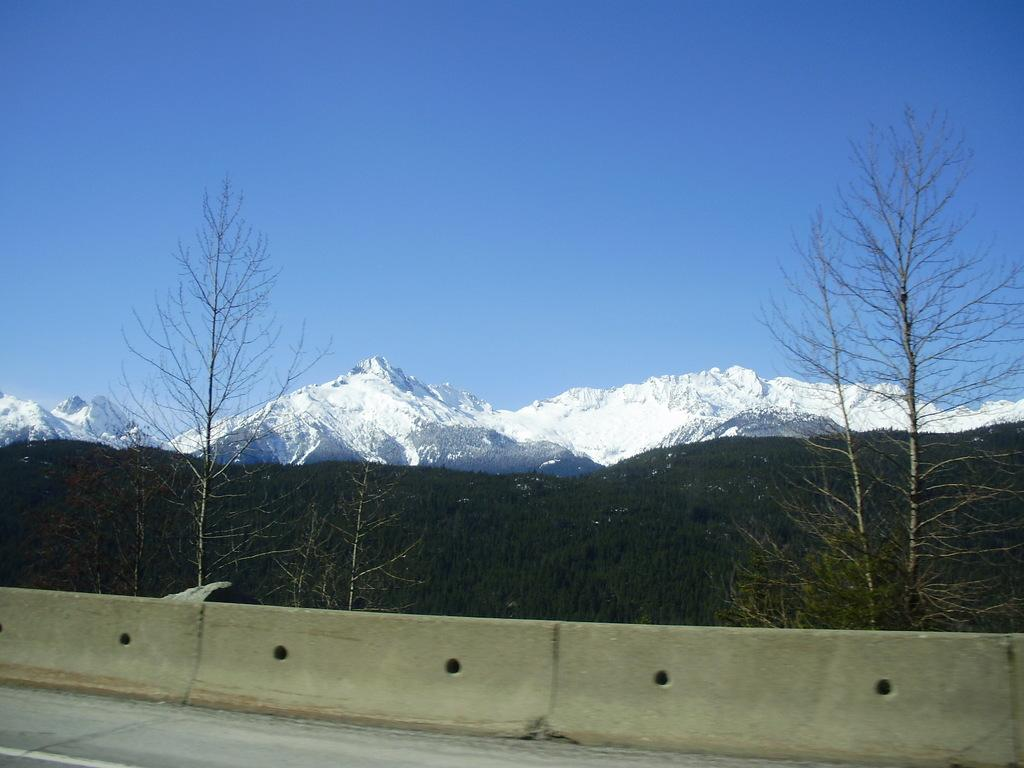What type of structure is located near the road in the image? There is a concrete wall near a road in the image. What can be seen in the distance behind the wall and road? There is a snow mountain in the background of the image. What type of vegetation is visible in the background of the image? There are trees in the background of the image. What is visible at the top of the image? The sky is visible at the top of the image. Can you see any sand or people swimming in the image? There is no sand or swimming activity visible in the image; it features a concrete wall, a road, a snow mountain, trees, and the sky. Is there a ball present in the image? There is no ball present in the image. 